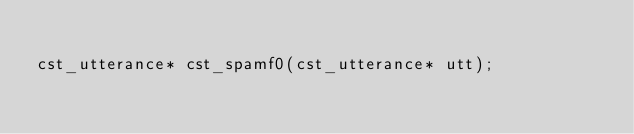<code> <loc_0><loc_0><loc_500><loc_500><_C++_>
cst_utterance* cst_spamf0(cst_utterance* utt);
</code> 